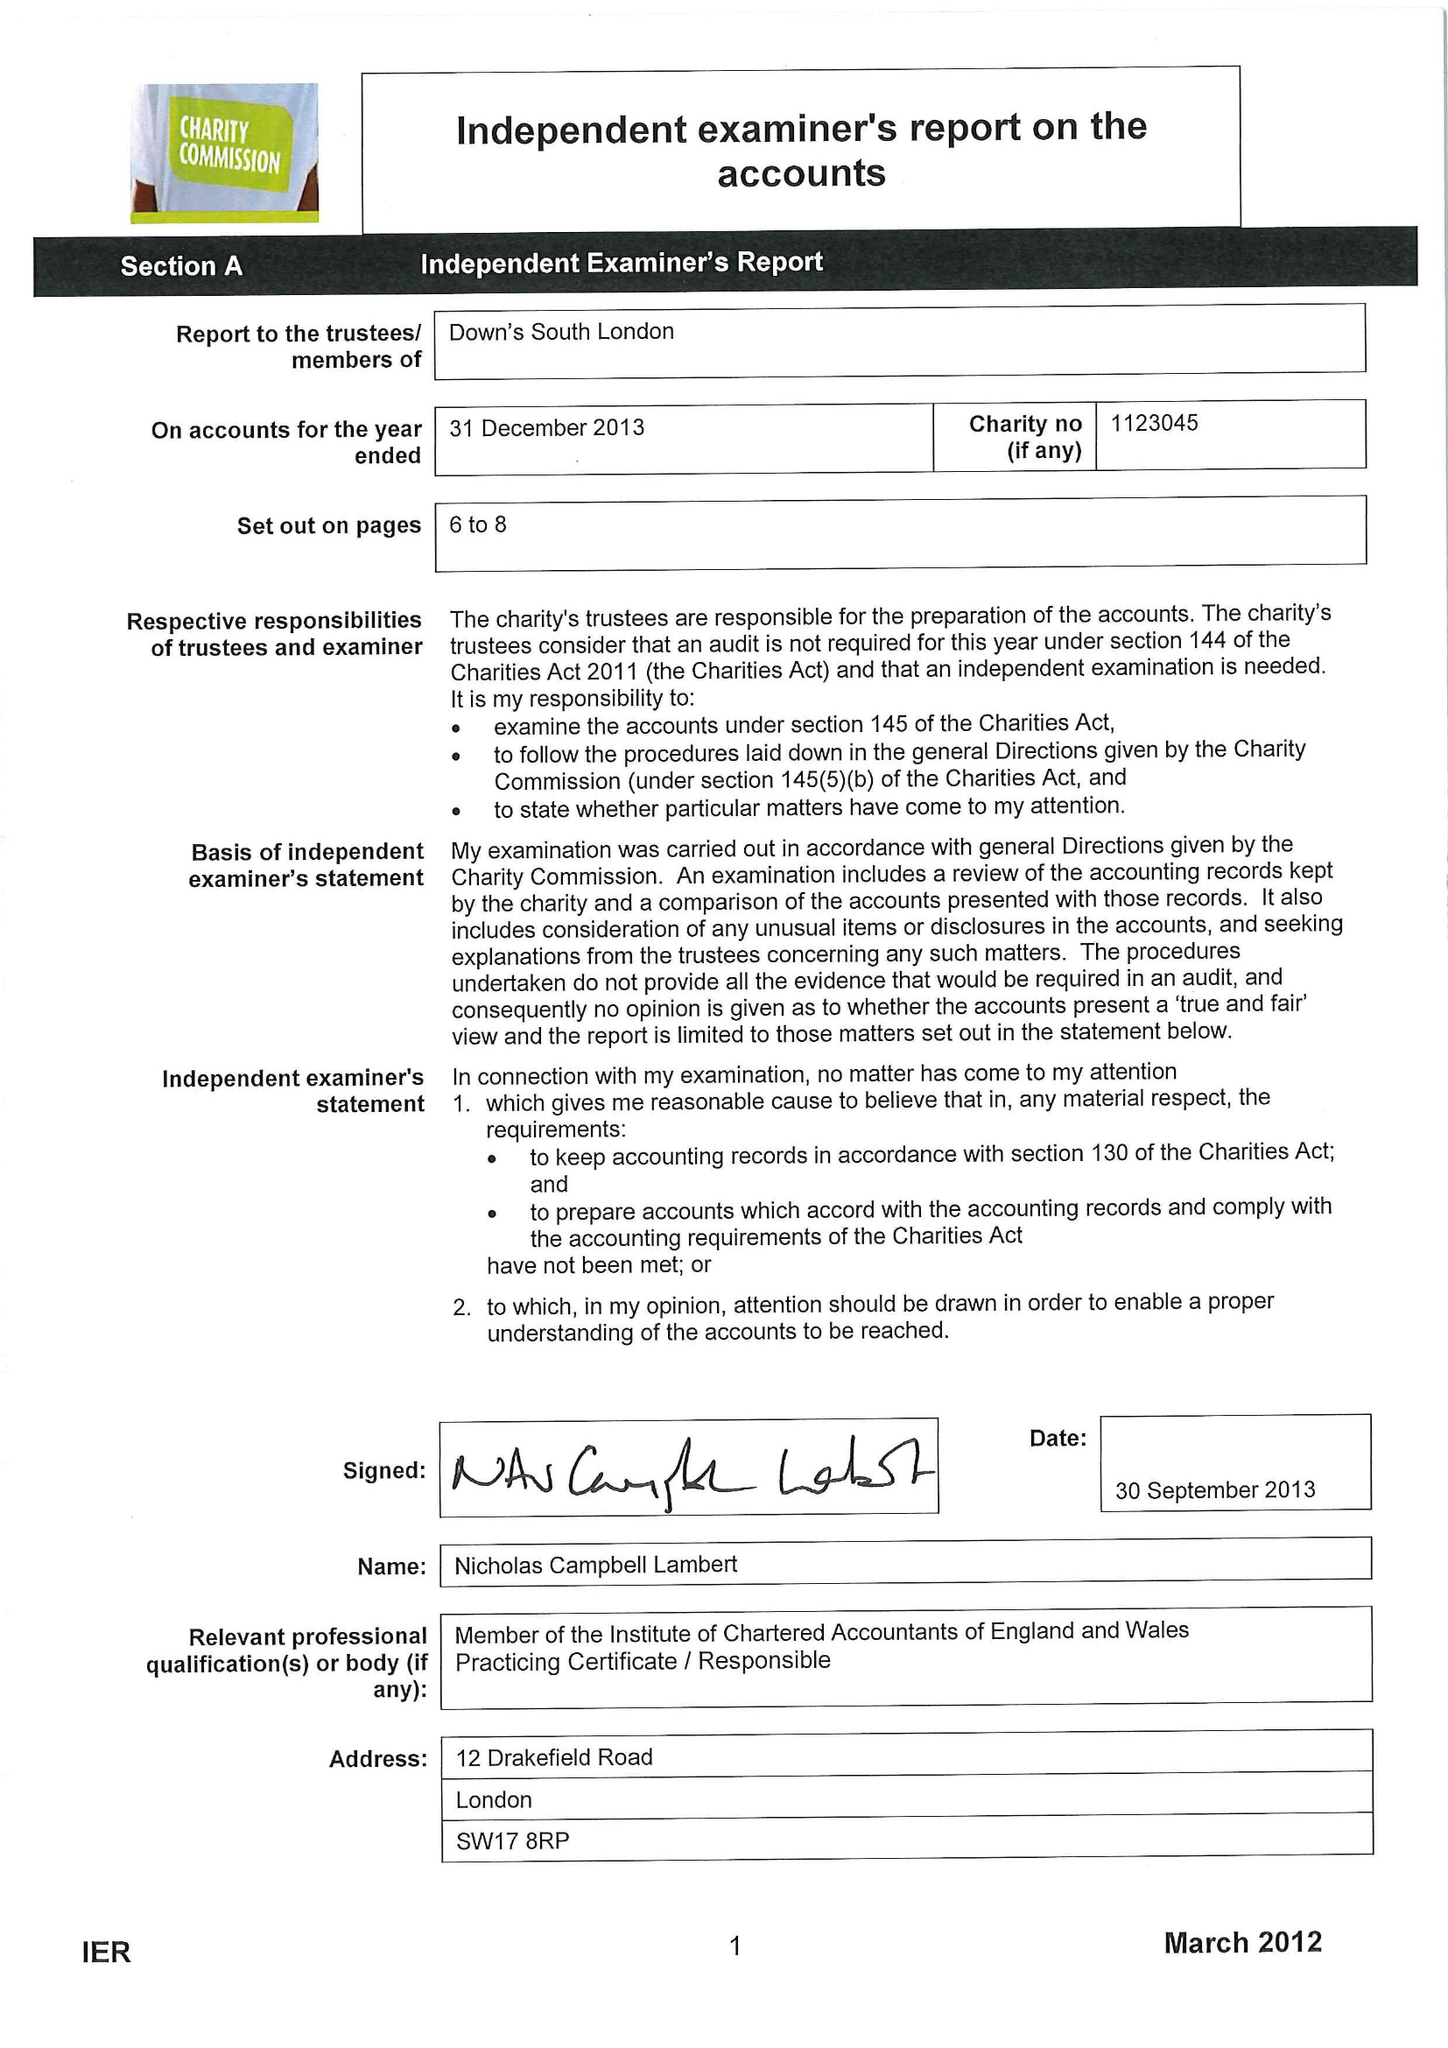What is the value for the report_date?
Answer the question using a single word or phrase. 2013-12-31 